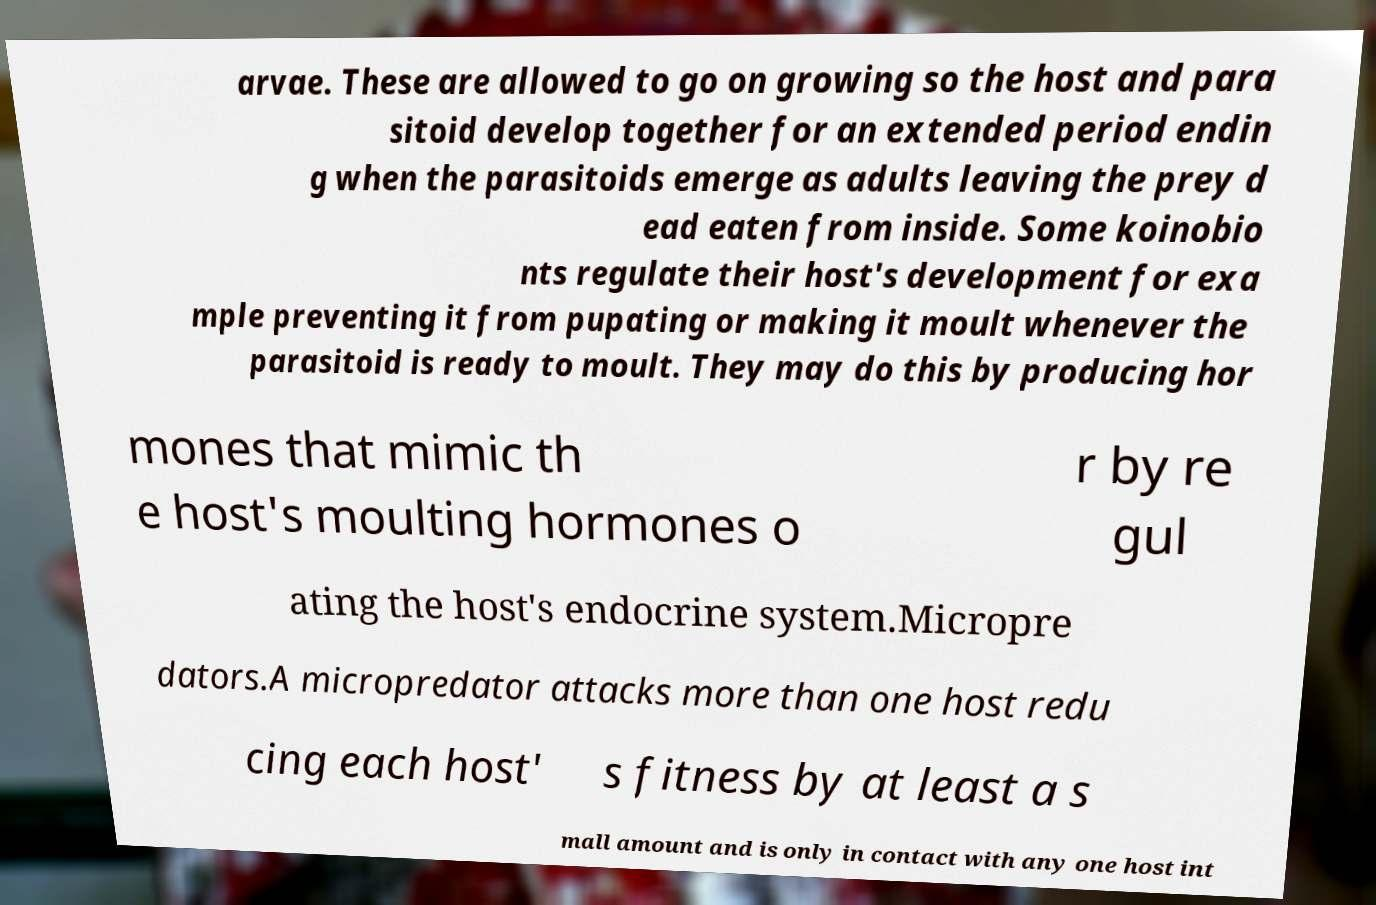Please read and relay the text visible in this image. What does it say? arvae. These are allowed to go on growing so the host and para sitoid develop together for an extended period endin g when the parasitoids emerge as adults leaving the prey d ead eaten from inside. Some koinobio nts regulate their host's development for exa mple preventing it from pupating or making it moult whenever the parasitoid is ready to moult. They may do this by producing hor mones that mimic th e host's moulting hormones o r by re gul ating the host's endocrine system.Micropre dators.A micropredator attacks more than one host redu cing each host' s fitness by at least a s mall amount and is only in contact with any one host int 